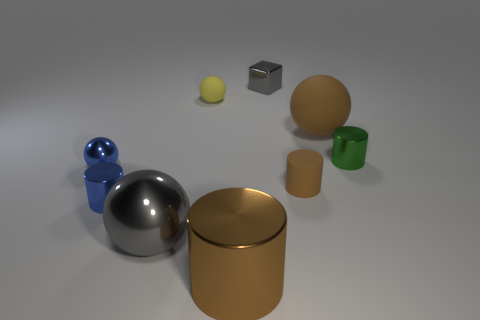What number of other objects are there of the same color as the big shiny ball?
Give a very brief answer. 1. What number of large gray metallic spheres are right of the gray object behind the small sphere behind the large matte sphere?
Provide a succinct answer. 0. There is a tiny rubber object that is the same shape as the big gray metallic thing; what color is it?
Your response must be concise. Yellow. The tiny blue metallic object that is to the right of the blue object that is to the left of the small cylinder on the left side of the block is what shape?
Make the answer very short. Cylinder. What is the size of the object that is in front of the small brown rubber cylinder and to the right of the yellow rubber object?
Make the answer very short. Large. Are there fewer blocks than small objects?
Your response must be concise. Yes. How big is the gray metallic thing that is in front of the tiny gray cube?
Offer a very short reply. Large. There is a small shiny thing that is behind the blue metal ball and in front of the tiny gray thing; what shape is it?
Offer a terse response. Cylinder. What is the size of the rubber object that is the same shape as the tiny green metallic object?
Give a very brief answer. Small. What number of small things are made of the same material as the blue cylinder?
Provide a short and direct response. 3. 